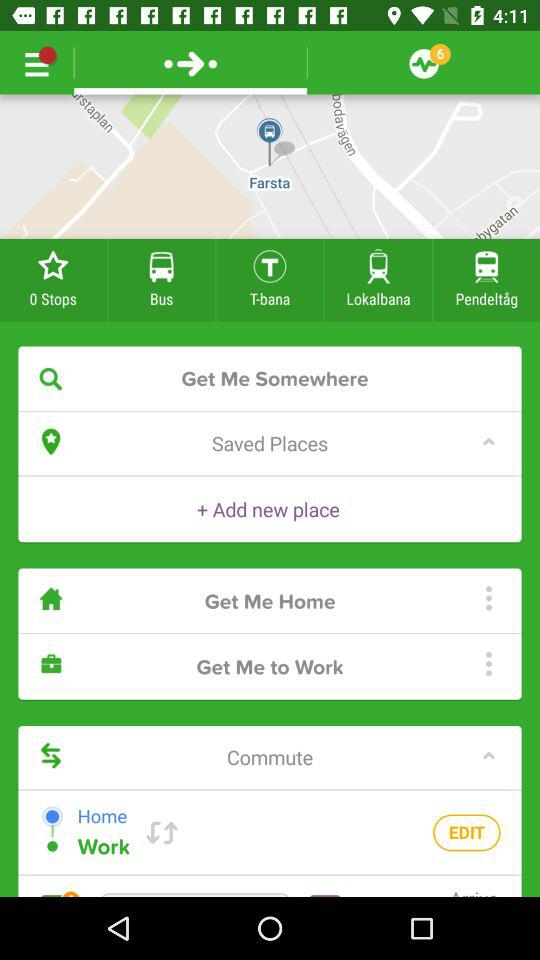How many stops are there? There are 0 stops. 